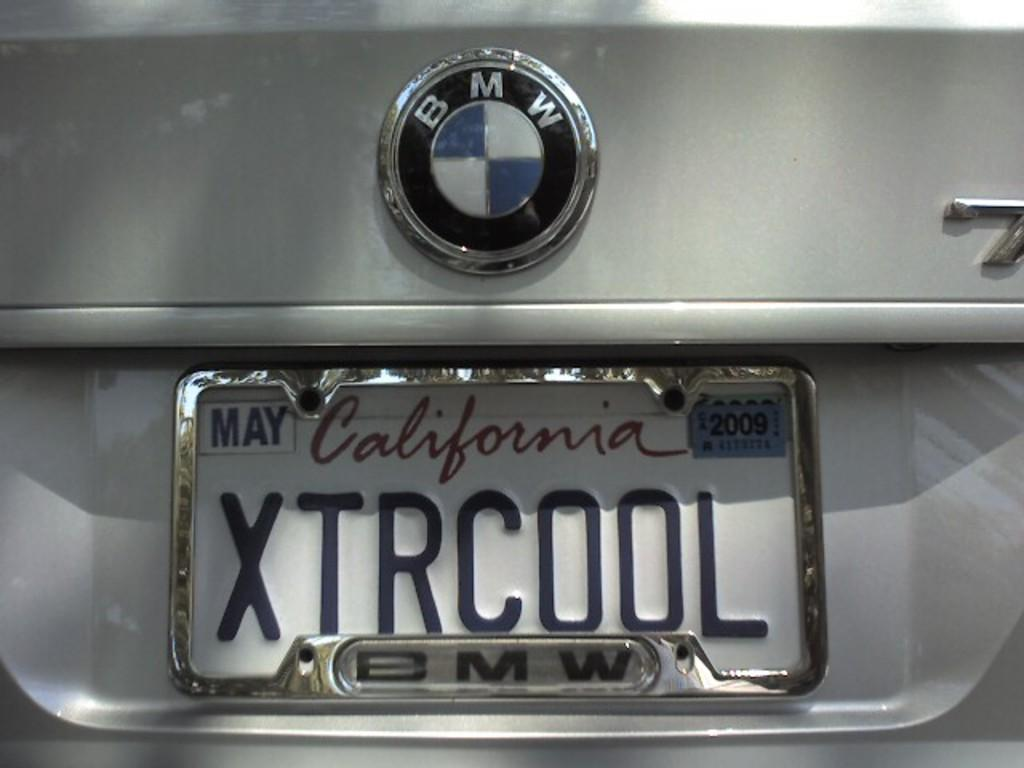What is the main subject of the image? The main subject of the image is a car. Can you describe any specific features of the car? Yes, the car has a number plate and a logo. Absurd Question/Answer: What type of collar is the committee wearing in the image? There is no committee or collar present in the image; it features a car with a number plate and a logo. What type of dad is depicted in the image? There is no dad present in the image; it features a car with a number plate and a logo. 